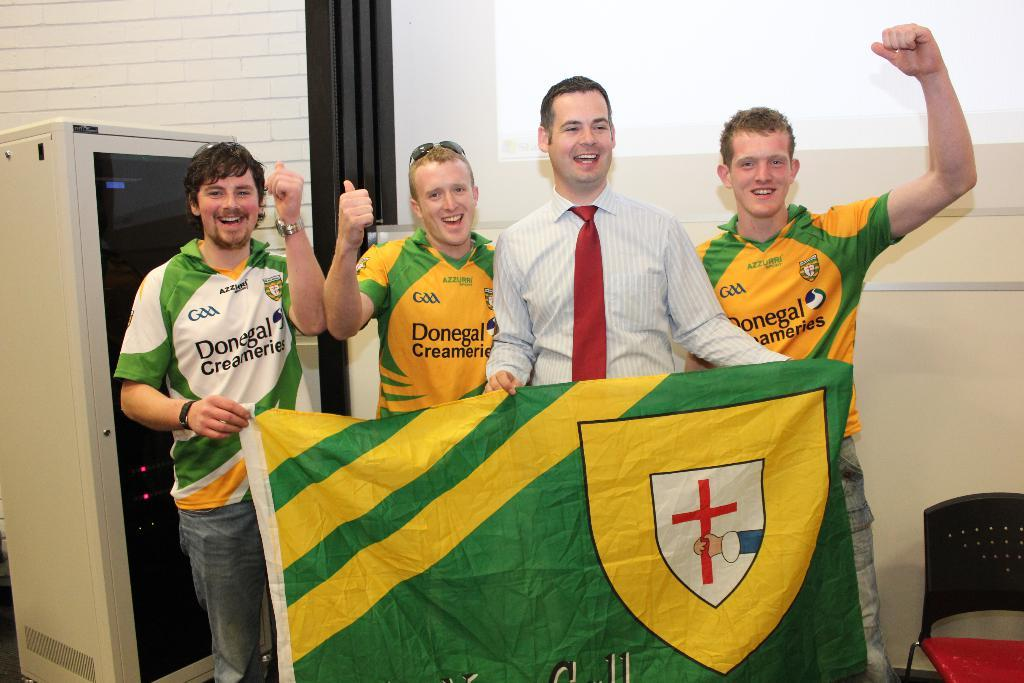<image>
Write a terse but informative summary of the picture. People for a sports team sponsored by Donegal Creameries pose with a flag. 